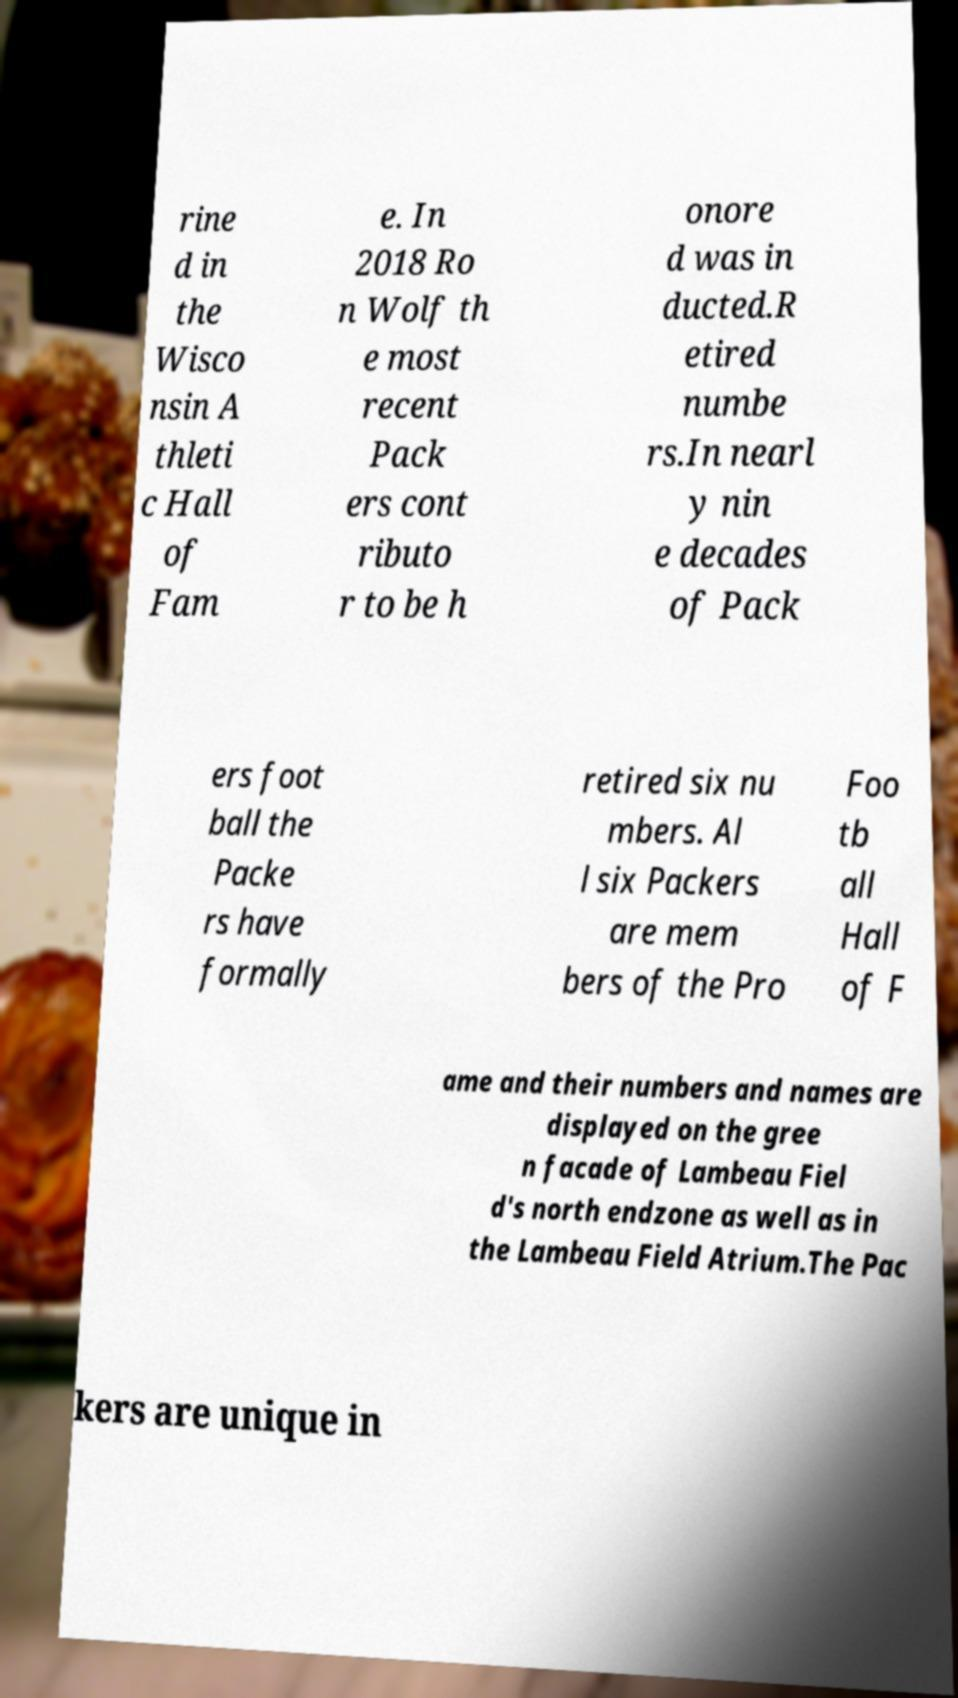Can you read and provide the text displayed in the image?This photo seems to have some interesting text. Can you extract and type it out for me? rine d in the Wisco nsin A thleti c Hall of Fam e. In 2018 Ro n Wolf th e most recent Pack ers cont ributo r to be h onore d was in ducted.R etired numbe rs.In nearl y nin e decades of Pack ers foot ball the Packe rs have formally retired six nu mbers. Al l six Packers are mem bers of the Pro Foo tb all Hall of F ame and their numbers and names are displayed on the gree n facade of Lambeau Fiel d's north endzone as well as in the Lambeau Field Atrium.The Pac kers are unique in 